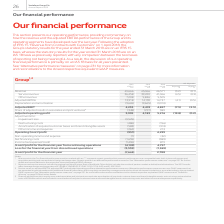According to Vodafone Group Plc's financial document, Which accounting standard was the Group's 2019 statutory results based on? According to the financial document, IFRS 15. The relevant text states: "2019 IFRS 15 €m..." Also, Which accounting standard was the Group's 2018 statutory results based on? According to the financial document, IAS 18. The relevant text states: "2019 IAS 18 €m..." Also, How much was the 2019 IAS 18 service revenue (in €m) ? According to the financial document, 39,220 (in millions). The relevant text states: "45,066 46,571 (3.2) (0.1) Service revenue 36,458 39,220 41,066 (4.5) (0.9) Other revenue 7,208 5,846 5,505 Adjusted EBITDA 13,918 14,139 14,737 (4.1) (0.5)..." Also, can you calculate: What is the average service revenue between 2018 and 2019 IAS 18? To answer this question, I need to perform calculations using the financial data. The calculation is: (39,220+41,066)/2, which equals 40143 (in millions). This is based on the information: "46,571 (3.2) (0.1) Service revenue 36,458 39,220 41,066 (4.5) (0.9) Other revenue 7,208 5,846 5,505 Adjusted EBITDA 13,918 14,139 14,737 (4.1) (0.5) Deprec 45,066 46,571 (3.2) (0.1) Service revenue 36..." The key data points involved are: 39,220, 41,066. Additionally, In 2019 IAS 18, which was the higher revenue segment? According to the financial document, Service revenue. The relevant text states: "ganic* % Revenue 43,666 45,066 46,571 (3.2) (0.1) Service revenue 36,458 39,220 41,066 (4.5) (0.9) Other revenue 7,208 5,846 5,505 Adjusted EBITDA 13,918 14,139 14,7..." Also, can you calculate: What is the difference between average service revenue and average other revenue? To answer this question, I need to perform calculations using the financial data. The calculation is: [(39,220+41,066)/2] - [(5,846+5,505)/2], which equals 34467.5 (in millions). This is based on the information: ",220 41,066 (4.5) (0.9) Other revenue 7,208 5,846 5,505 Adjusted EBITDA 13,918 14,139 14,737 (4.1) (0.5) Depreciation and amortisation (9,665) (9,665) (9,9 45,066 46,571 (3.2) (0.1) Service revenue 36..." The key data points involved are: 2, 39,220, 41,066. 